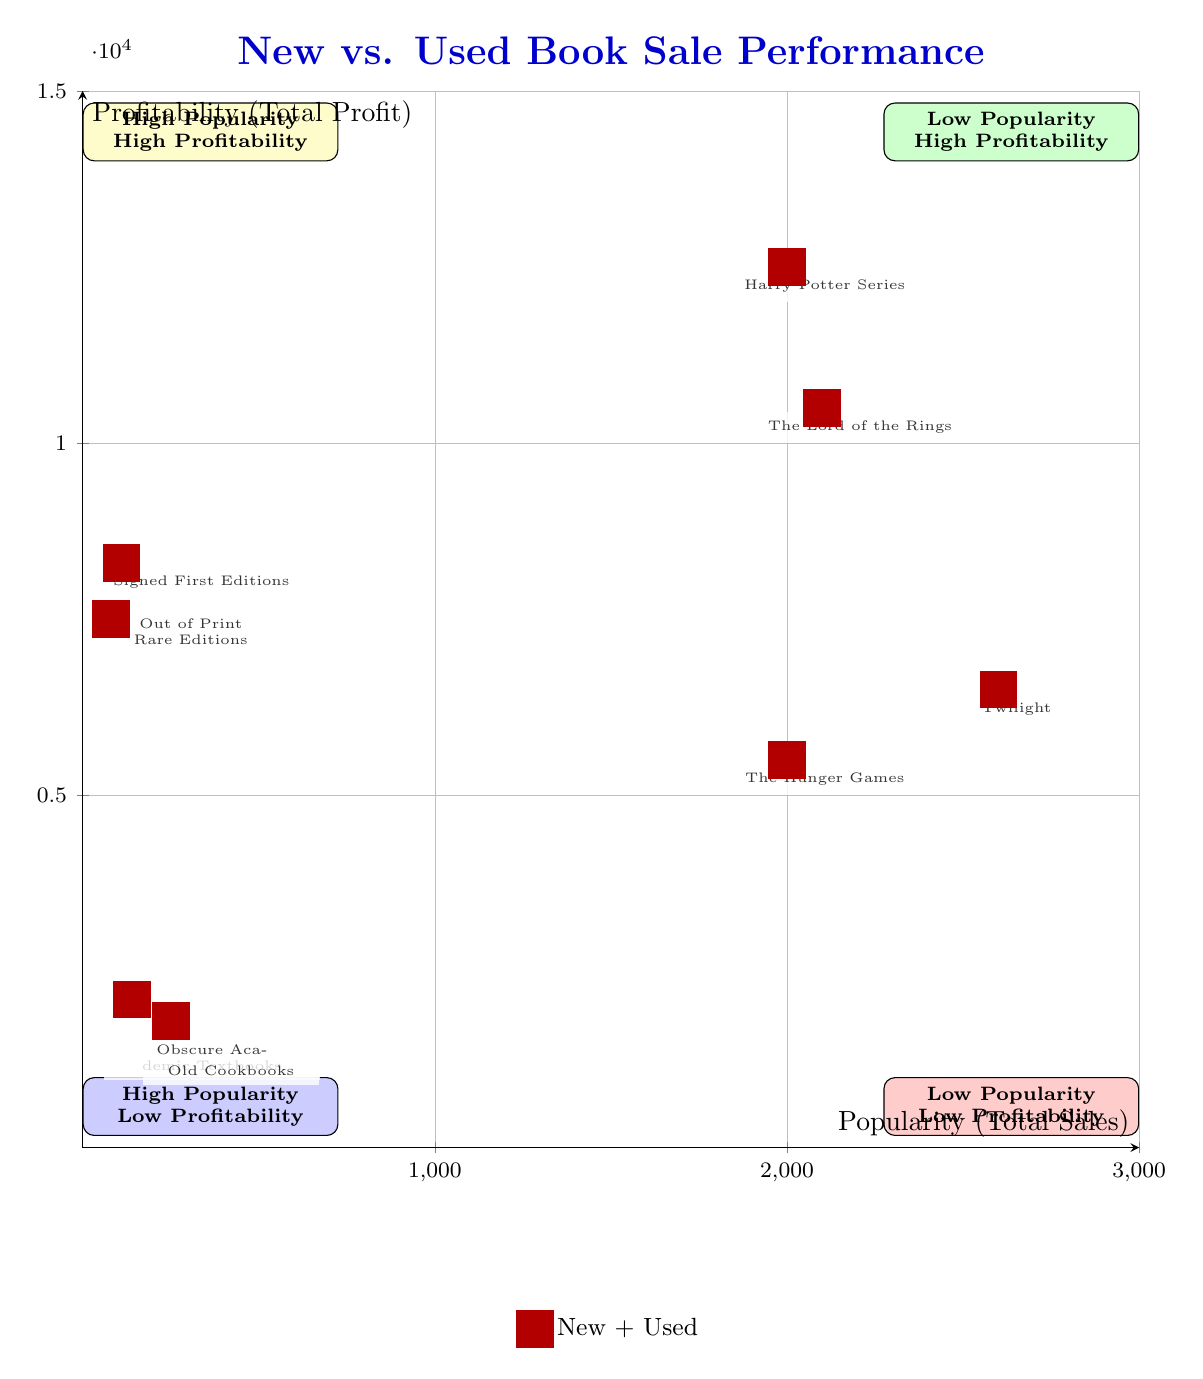What are the titles in the High Popularity, High Profitability quadrant? The High Popularity, High Profitability quadrant contains the titles Harry Potter Series and The Lord of the Rings.
Answer: Harry Potter Series, The Lord of the Rings How many total sales did Twilight achieve? In the High Popularity, Low Profitability quadrant, Twilight had new book sales of 1200 and used book sales of 1400, summing up to a total of 1200 + 1400 = 2600 sales.
Answer: 2600 Which book has the highest profitability in the Low Popularity, High Profitability quadrant? Out of Print Rare Editions has a profitability of 4000, while Signed First Editions has a profitability of 4500. Therefore, the book with the highest profitability here is Signed First Editions.
Answer: Signed First Editions What is the profit from used book sales for the Harry Potter Series? The used book profit for the Harry Potter Series is stated directly in its data as 7500.
Answer: 7500 Which quadrant has the lowest total profit across its elements? The Low Popularity, Low Profitability quadrant has the lowest total profit with Obscure Academic Textbooks at 1200 and Old Cookbooks at 1000, summing up to a total profit of 1200 + 1000 = 2200.
Answer: Low Popularity, Low Profitability What is the total number of new book sales for the titles in the High Popularity, Low Profitability quadrant? The new book sales for Twilight are 1200 and for The Hunger Games are 900. Adding these gives us a total of 1200 + 900 = 2100 new book sales.
Answer: 2100 How many elements are there in the Low Popularity, High Profitability quadrant? The Low Popularity, High Profitability quadrant contains two elements: Out of Print Rare Editions and Signed First Editions.
Answer: 2 What is the profitability for used book sales of The Hunger Games? In the diagram, the used book profit for The Hunger Games is listed as 3000.
Answer: 3000 